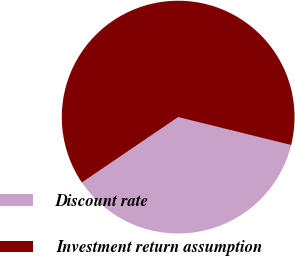Convert chart. <chart><loc_0><loc_0><loc_500><loc_500><pie_chart><fcel>Discount rate<fcel>Investment return assumption<nl><fcel>36.65%<fcel>63.35%<nl></chart> 